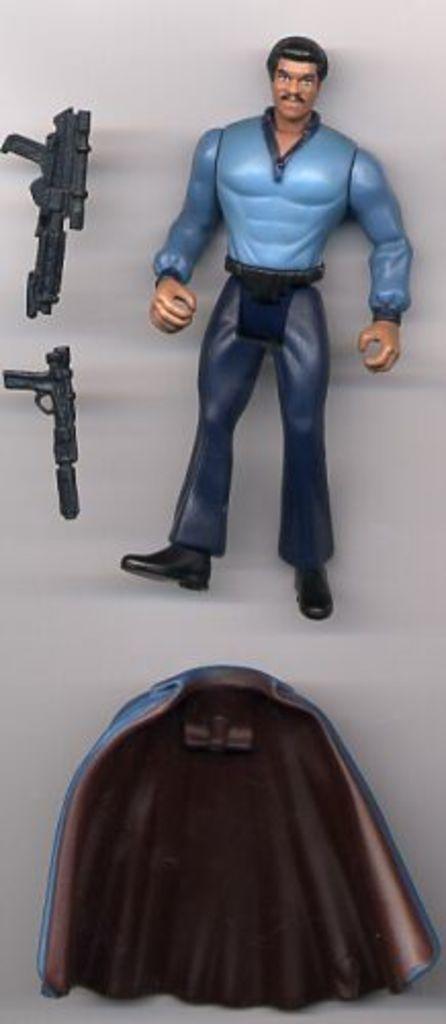Could you give a brief overview of what you see in this image? In this image there is a toy of a person, two guns and some other object. 